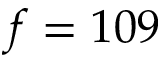<formula> <loc_0><loc_0><loc_500><loc_500>f = 1 0 9</formula> 